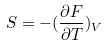Convert formula to latex. <formula><loc_0><loc_0><loc_500><loc_500>S = - ( \frac { \partial F } { \partial T } ) _ { V }</formula> 